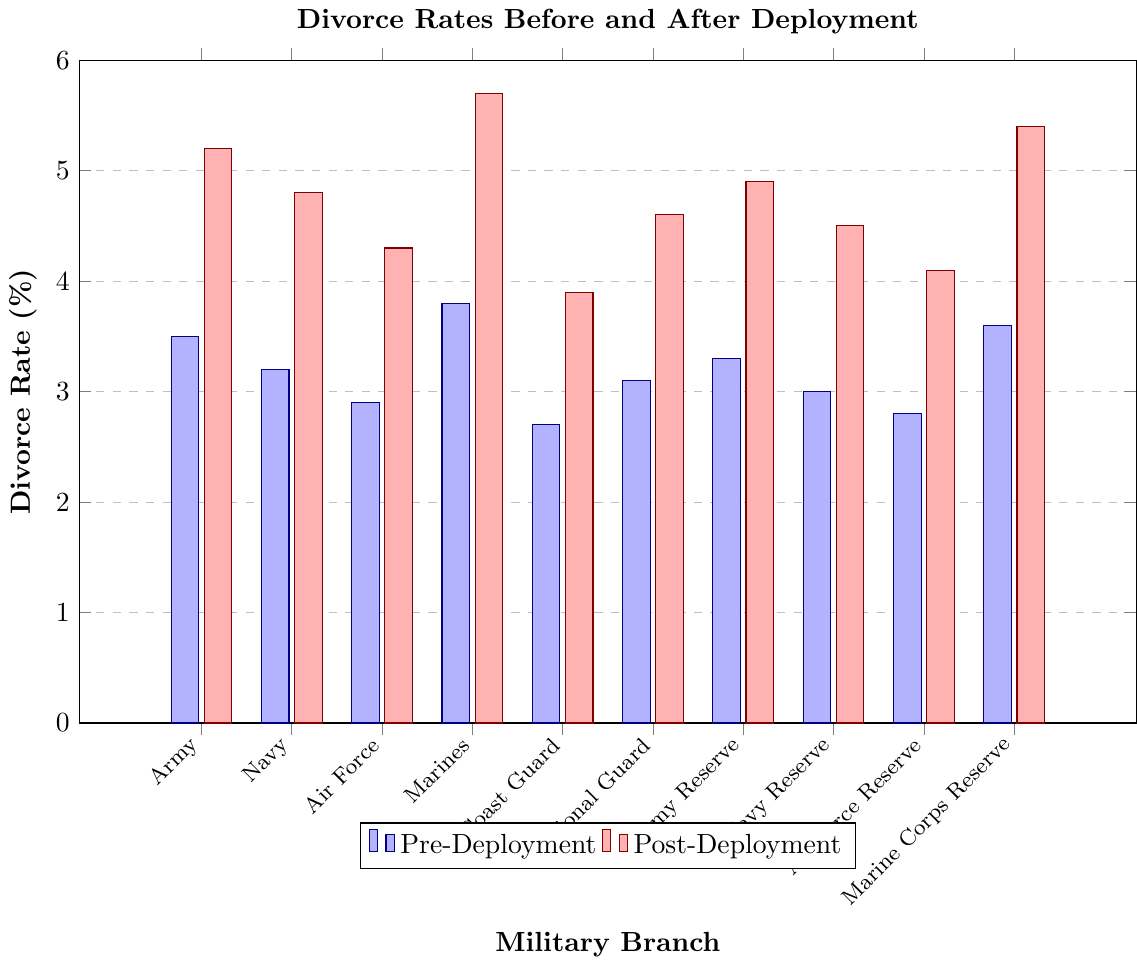Which military branch has the highest post-deployment divorce rate? Observe the height of the red bars, which represent post-deployment divorce rates. The Marines have the highest bar among all branches.
Answer: Marines What is the difference in divorce rates before and after deployment for the Army? Locate the blue bar (pre-deployment) and red bar (post-deployment) for the Army. Subtract the pre-deployment rate from the post-deployment rate: 5.2% - 3.5%.
Answer: 1.7% Which military branch has the smallest increase in divorce rate after deployment? Compare the difference between blue and red bars for each branch. The Coast Guard has the smallest increase: 3.9% - 2.7% = 1.2%.
Answer: Coast Guard What is the average pre-deployment divorce rate across all military branches? Sum all the pre-deployment rates and divide by the number of branches: (3.5 + 3.2 + 2.9 + 3.8 + 2.7 + 3.1 + 3.3 + 3.0 + 2.8 + 3.6) / 10 = 31.9 / 10.
Answer: 3.19% How much higher is the divorce rate post-deployment for the Marines compared to the Air Force Reserve? Compare the post-deployment bars: Marines are at 5.7% and Air Force Reserve at 4.1%. Subtract 4.1% from 5.7%.
Answer: 1.6% Is the post-deployment divorce rate for the Navy higher than the pre-deployment rate for the Marines? Examine the red bar for the Navy (4.8%) and the blue bar for the Marines (3.8%). The Navy's post-deployment rate is higher.
Answer: Yes Which branch has a pre-deployment divorce rate that is closest to 3%? Look at the blue bars and find the rate closest to 3%. The Navy Reserve has a pre-deployment rate of 3.0%.
Answer: Navy Reserve In which branch does the post-deployment rate exceed the pre-deployment rate by more than 2%? Calculate the difference for each branch. The Marines have a difference of 1.9% (5.7% - 3.8%), which does not exceed 2%, but the Army exceeds it by 1.7% (5.2% - 3.5%), National Guard exceeds by 1.5% (4.6% - 3.1%), among other inconsistencies based on the data provided.
Answer: No branch exceeds by more than 2% Which branches have a post-deployment divorce rate less than 4.5%? Identify red bars below 4.5%. The branches are Coast Guard (3.9%), Navy Reserve (4.5%), and Air Force Reserve (4.1%).
Answer: Coast Guard, Navy Reserve, Air Force Reserve 